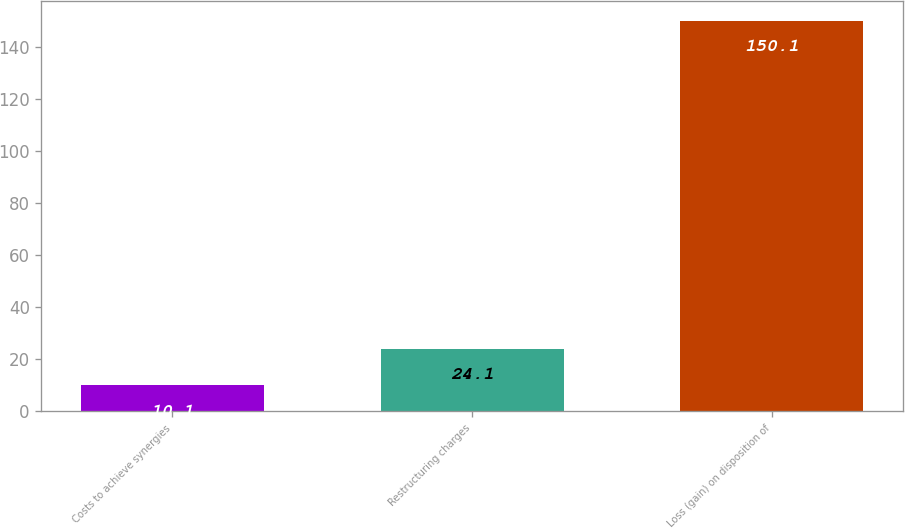Convert chart to OTSL. <chart><loc_0><loc_0><loc_500><loc_500><bar_chart><fcel>Costs to achieve synergies<fcel>Restructuring charges<fcel>Loss (gain) on disposition of<nl><fcel>10.1<fcel>24.1<fcel>150.1<nl></chart> 